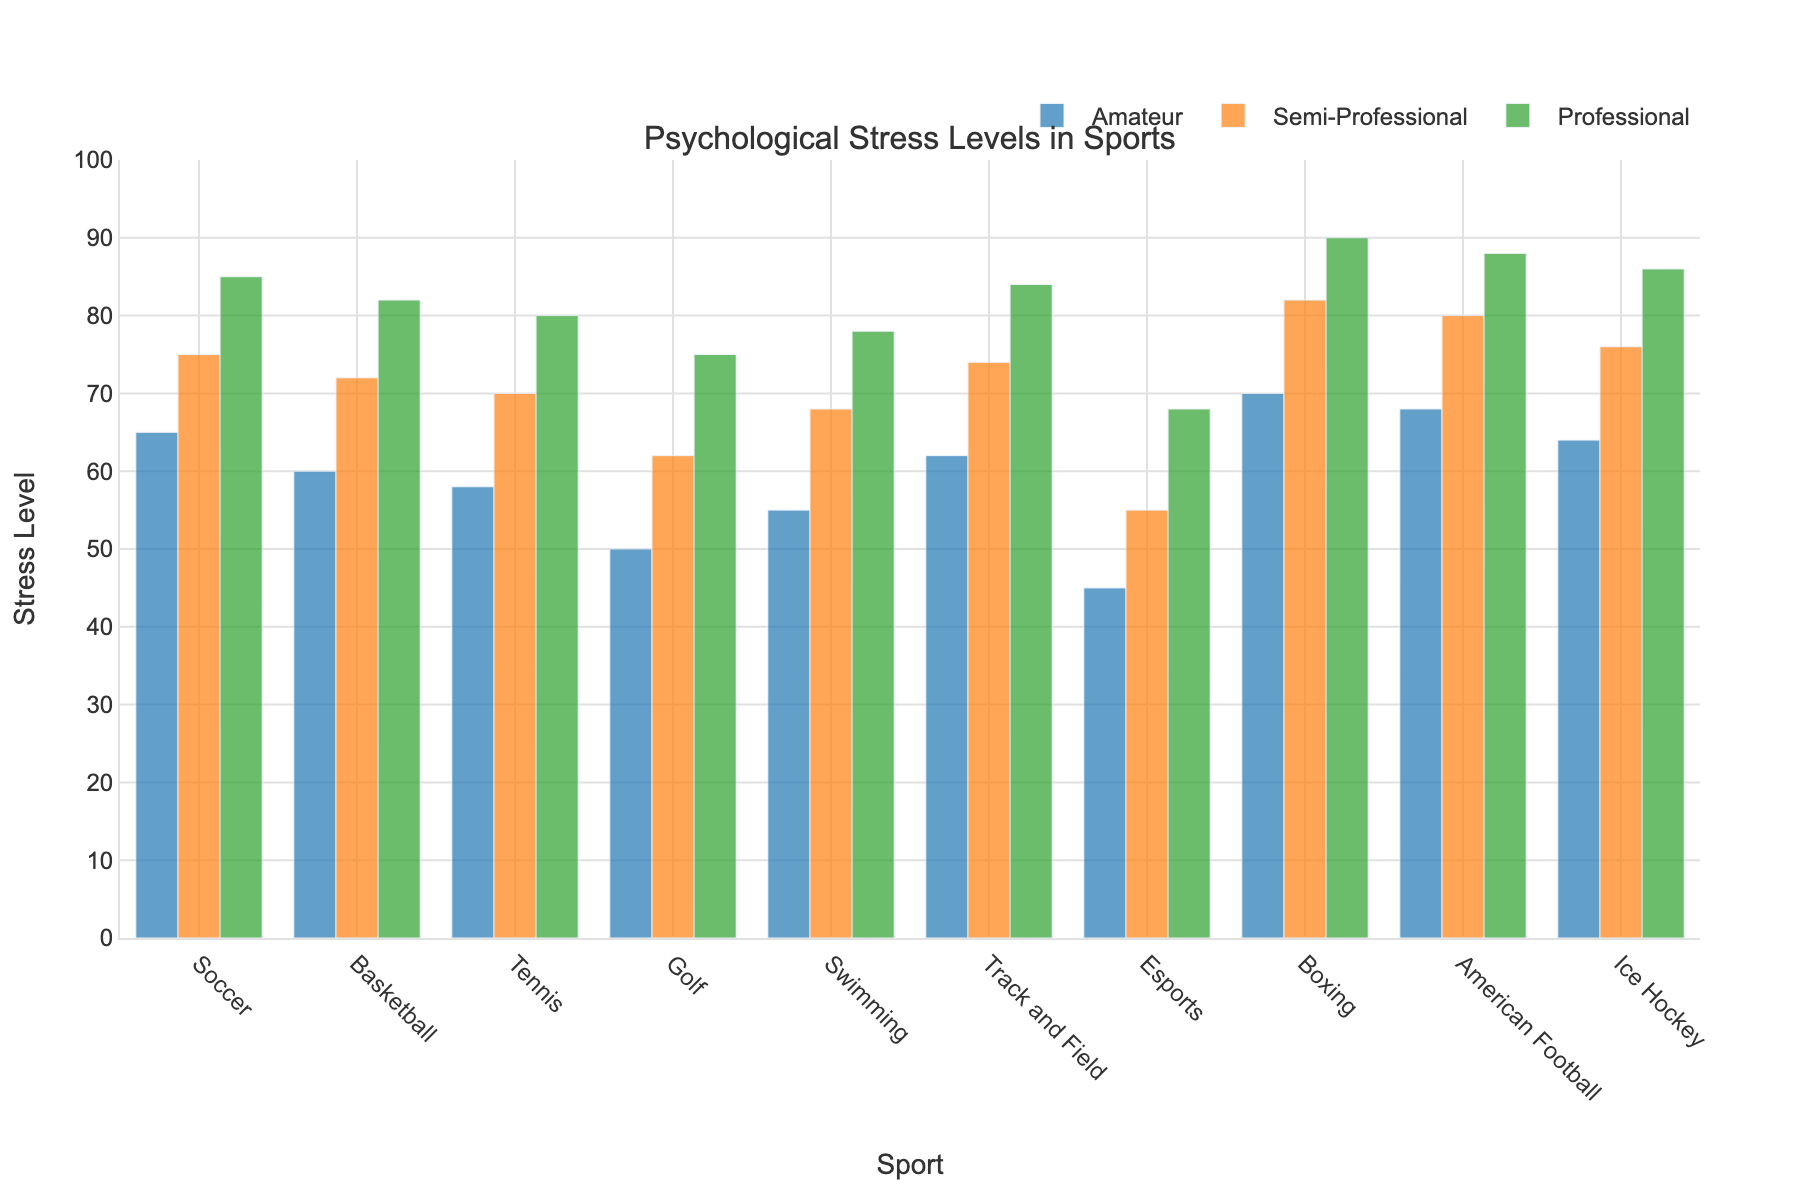Which sport shows the highest stress levels across all competition levels? Boxing has the highest stress levels in all competition levels—Amateur (70), Semi-Professional (82), and Professional (90).
Answer: Boxing Which sport has the lowest stress levels in the Professional category? Esports shows the lowest stress levels in the Professional category with a value of 68.
Answer: Esports How much higher is the stress level in Professional Soccer compared to Amateur Soccer? The stress level in Professional Soccer is 85, and in Amateur Soccer it is 65. The difference is 85 - 65 = 20.
Answer: 20 What is the average stress level for Semi-Professional Basketball and Tennis? The stress level for Semi-Professional Basketball is 72 and for Tennis is 70. The average is (72 + 70) / 2 = 71.
Answer: 71 Which is greater: the stress level in Professional Tennis or Semi-Professional Boxing? The stress level in Professional Tennis is 80 while in Semi-Professional Boxing it is 82. 82 is greater than 80.
Answer: Semi-Professional Boxing Are the stress levels in Semi-Professional Soccer and Semi-Professional Ice Hockey equal? The stress level in Semi-Professional Soccer is 75 and in Semi-Professional Ice Hockey is 76. They are not equal.
Answer: No Between which competition levels in Esports do we see the greatest increase in stress levels? The stress levels in Esports for Amateur, Semi-Professional, and Professional are 45, 55, and 68 respectively. The increase from Amateur to Semi-Professional is 55 - 45 = 10, and from Semi-Professional to Professional is 68 - 55 = 13. The greatest increase is from Semi-Professional to Professional.
Answer: Semi-Professional to Professional If we consider Boxing as an outlier with exceptionally high stress levels, which sport has the second highest stress level in the Professional category? Excluding Boxing, American Football has the second highest stress level in the Professional category with a value of 88.
Answer: American Football What is the total stress level for all sports in the Amateur level combined? Summing the stress levels for all sports in the Amateur level: Soccer (65) + Basketball (60) + Tennis (58) + Golf (50) + Swimming (55) + Track and Field (62) + Esports (45) + Boxing (70) + American Football (68) + Ice Hockey (64) = 597.
Answer: 597 